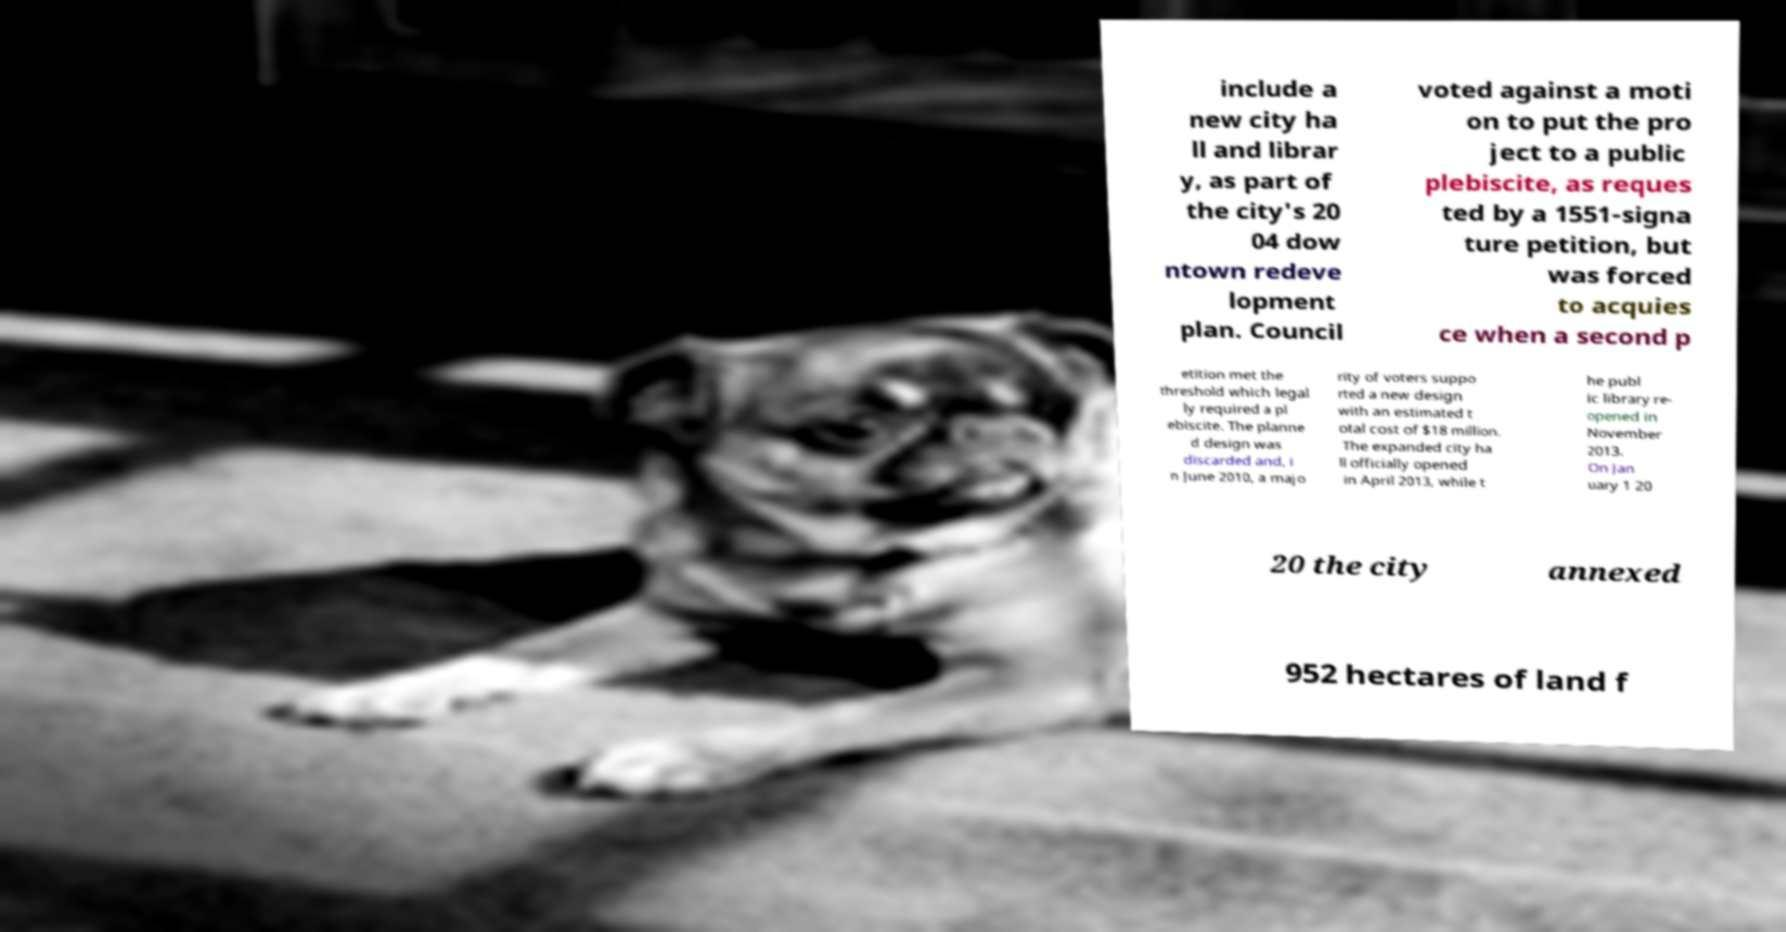Can you accurately transcribe the text from the provided image for me? include a new city ha ll and librar y, as part of the city's 20 04 dow ntown redeve lopment plan. Council voted against a moti on to put the pro ject to a public plebiscite, as reques ted by a 1551-signa ture petition, but was forced to acquies ce when a second p etition met the threshold which legal ly required a pl ebiscite. The planne d design was discarded and, i n June 2010, a majo rity of voters suppo rted a new design with an estimated t otal cost of $18 million. The expanded city ha ll officially opened in April 2013, while t he publ ic library re- opened in November 2013. On Jan uary 1 20 20 the city annexed 952 hectares of land f 